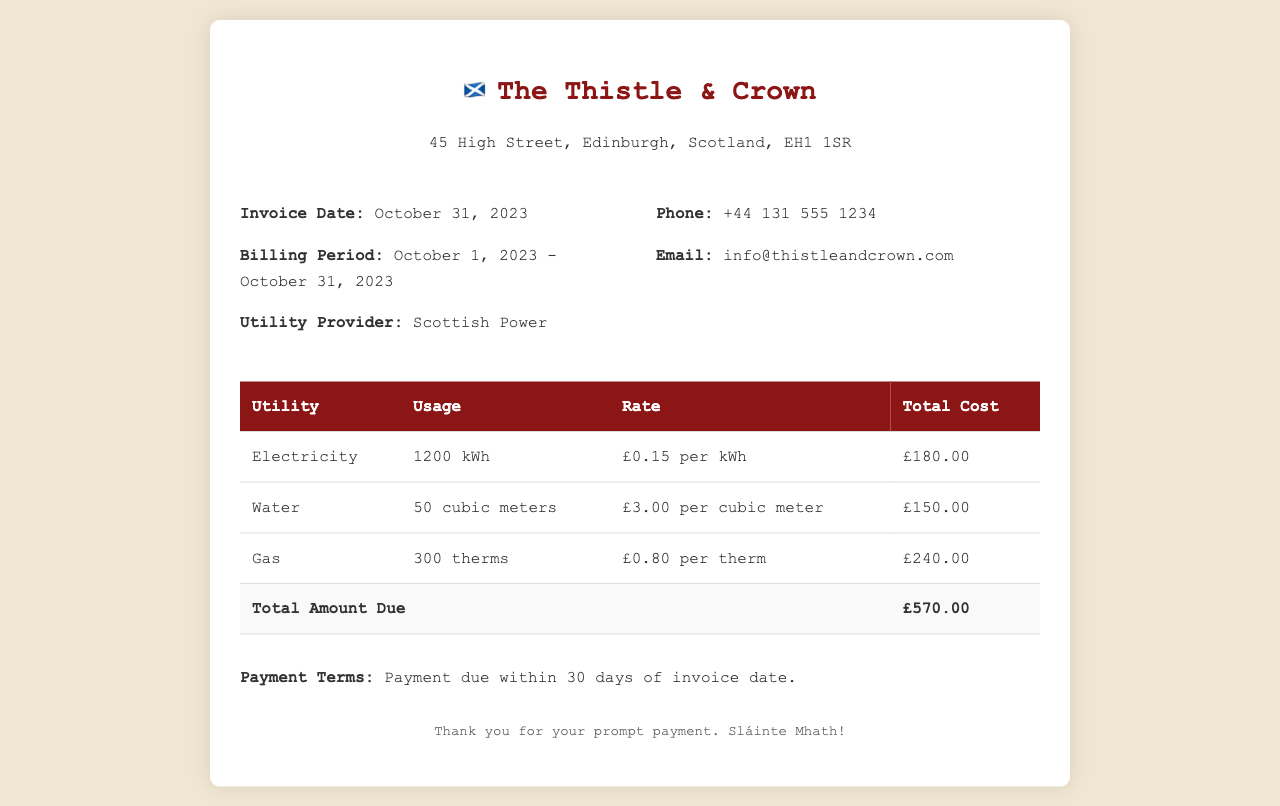What is the invoice date? The invoice date is clearly stated in the document and is specified as October 31, 2023.
Answer: October 31, 2023 What is the total cost for gas? The gas usage and its rate are listed, and calculating the total gives £240.00 for gas.
Answer: £240.00 What is the billing period? The billing period is detailed in the document, which shows it covers from October 1, 2023 to October 31, 2023.
Answer: October 1, 2023 - October 31, 2023 What is the rate for water? The rate for water usage is provided in the invoice and is £3.00 per cubic meter.
Answer: £3.00 per cubic meter What is the total amount due? The total amount due is clearly indicated in the totals row of the table, amounting to £570.00.
Answer: £570.00 How many cubic meters of water were used? The usage for water is specified in the invoice as 50 cubic meters.
Answer: 50 cubic meters Which utility provider is listed? The utility provider is explicitly mentioned in the document, which states Scottish Power.
Answer: Scottish Power What is the rate for electricity? The rate for electricity is detailed in the table and is £0.15 per kWh.
Answer: £0.15 per kWh What is the contact phone number? The phone number for contact is provided and noted as +44 131 555 1234.
Answer: +44 131 555 1234 